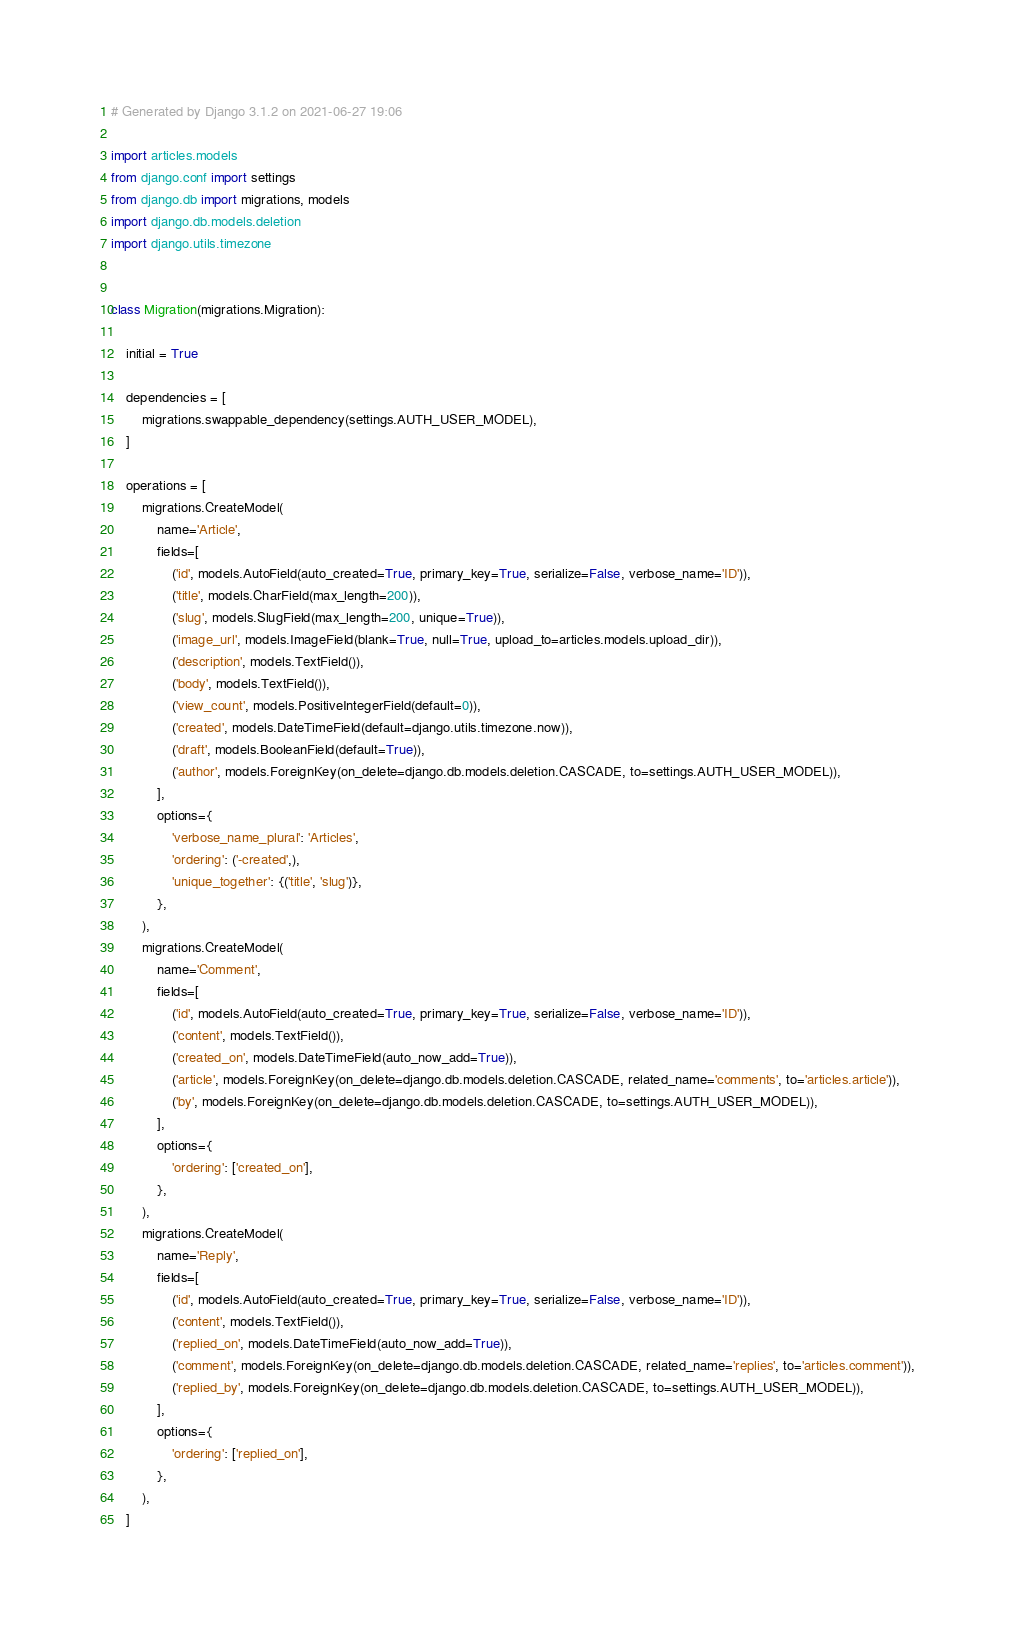<code> <loc_0><loc_0><loc_500><loc_500><_Python_># Generated by Django 3.1.2 on 2021-06-27 19:06

import articles.models
from django.conf import settings
from django.db import migrations, models
import django.db.models.deletion
import django.utils.timezone


class Migration(migrations.Migration):

    initial = True

    dependencies = [
        migrations.swappable_dependency(settings.AUTH_USER_MODEL),
    ]

    operations = [
        migrations.CreateModel(
            name='Article',
            fields=[
                ('id', models.AutoField(auto_created=True, primary_key=True, serialize=False, verbose_name='ID')),
                ('title', models.CharField(max_length=200)),
                ('slug', models.SlugField(max_length=200, unique=True)),
                ('image_url', models.ImageField(blank=True, null=True, upload_to=articles.models.upload_dir)),
                ('description', models.TextField()),
                ('body', models.TextField()),
                ('view_count', models.PositiveIntegerField(default=0)),
                ('created', models.DateTimeField(default=django.utils.timezone.now)),
                ('draft', models.BooleanField(default=True)),
                ('author', models.ForeignKey(on_delete=django.db.models.deletion.CASCADE, to=settings.AUTH_USER_MODEL)),
            ],
            options={
                'verbose_name_plural': 'Articles',
                'ordering': ('-created',),
                'unique_together': {('title', 'slug')},
            },
        ),
        migrations.CreateModel(
            name='Comment',
            fields=[
                ('id', models.AutoField(auto_created=True, primary_key=True, serialize=False, verbose_name='ID')),
                ('content', models.TextField()),
                ('created_on', models.DateTimeField(auto_now_add=True)),
                ('article', models.ForeignKey(on_delete=django.db.models.deletion.CASCADE, related_name='comments', to='articles.article')),
                ('by', models.ForeignKey(on_delete=django.db.models.deletion.CASCADE, to=settings.AUTH_USER_MODEL)),
            ],
            options={
                'ordering': ['created_on'],
            },
        ),
        migrations.CreateModel(
            name='Reply',
            fields=[
                ('id', models.AutoField(auto_created=True, primary_key=True, serialize=False, verbose_name='ID')),
                ('content', models.TextField()),
                ('replied_on', models.DateTimeField(auto_now_add=True)),
                ('comment', models.ForeignKey(on_delete=django.db.models.deletion.CASCADE, related_name='replies', to='articles.comment')),
                ('replied_by', models.ForeignKey(on_delete=django.db.models.deletion.CASCADE, to=settings.AUTH_USER_MODEL)),
            ],
            options={
                'ordering': ['replied_on'],
            },
        ),
    ]
</code> 